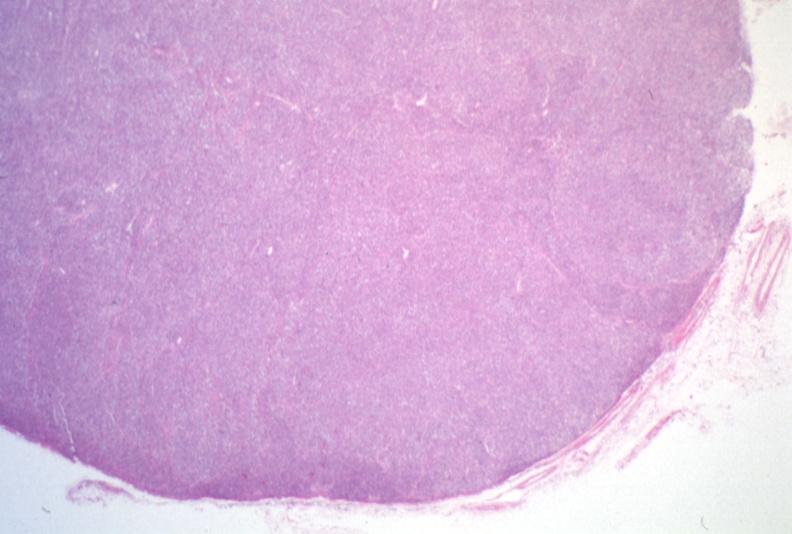what does this image show?
Answer the question using a single word or phrase. Lymph node 